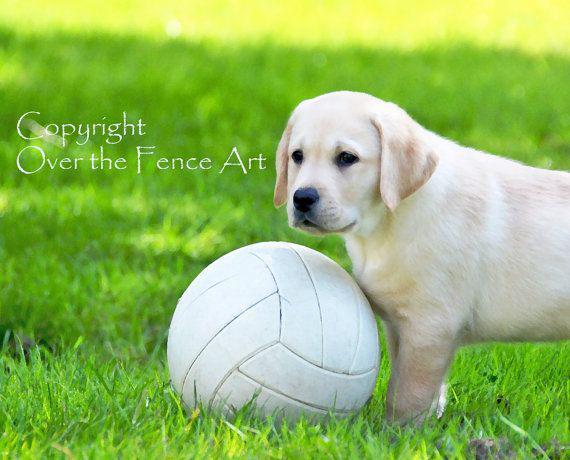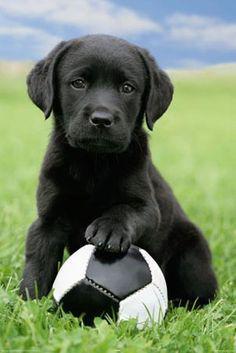The first image is the image on the left, the second image is the image on the right. Examine the images to the left and right. Is the description "The dog in the image on the right has one paw resting on a ball." accurate? Answer yes or no. Yes. The first image is the image on the left, the second image is the image on the right. For the images displayed, is the sentence "Each image shows a puppy posed with a sports ball, and the puppy on the right is sitting behind a soccer ball with one paw atop it." factually correct? Answer yes or no. Yes. 